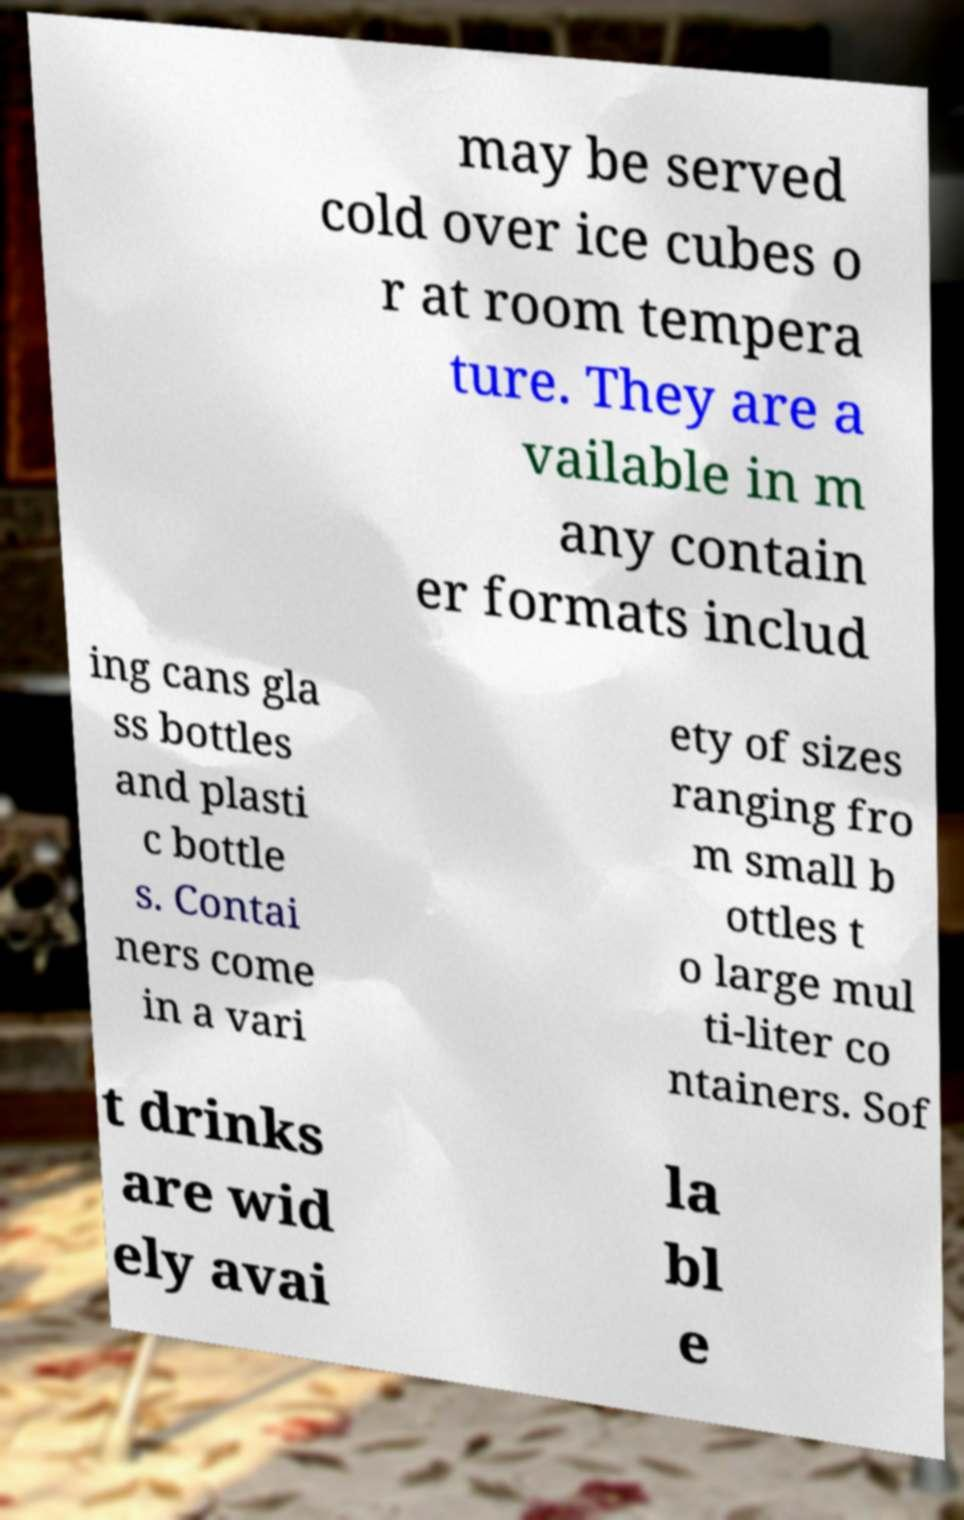What messages or text are displayed in this image? I need them in a readable, typed format. may be served cold over ice cubes o r at room tempera ture. They are a vailable in m any contain er formats includ ing cans gla ss bottles and plasti c bottle s. Contai ners come in a vari ety of sizes ranging fro m small b ottles t o large mul ti-liter co ntainers. Sof t drinks are wid ely avai la bl e 